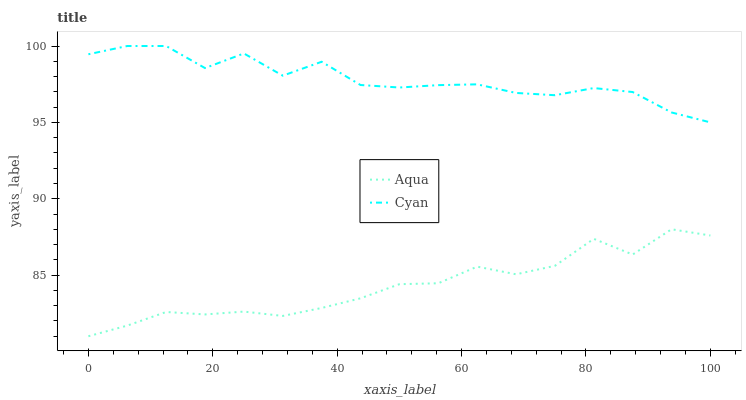Does Aqua have the minimum area under the curve?
Answer yes or no. Yes. Does Cyan have the maximum area under the curve?
Answer yes or no. Yes. Does Aqua have the maximum area under the curve?
Answer yes or no. No. Is Aqua the smoothest?
Answer yes or no. Yes. Is Cyan the roughest?
Answer yes or no. Yes. Is Aqua the roughest?
Answer yes or no. No. Does Aqua have the highest value?
Answer yes or no. No. Is Aqua less than Cyan?
Answer yes or no. Yes. Is Cyan greater than Aqua?
Answer yes or no. Yes. Does Aqua intersect Cyan?
Answer yes or no. No. 